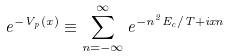Convert formula to latex. <formula><loc_0><loc_0><loc_500><loc_500>e ^ { - V _ { p } ( x ) } \equiv \sum _ { n = - \infty } ^ { \infty } e ^ { - n ^ { 2 } E _ { c } / T + i x n } \,</formula> 